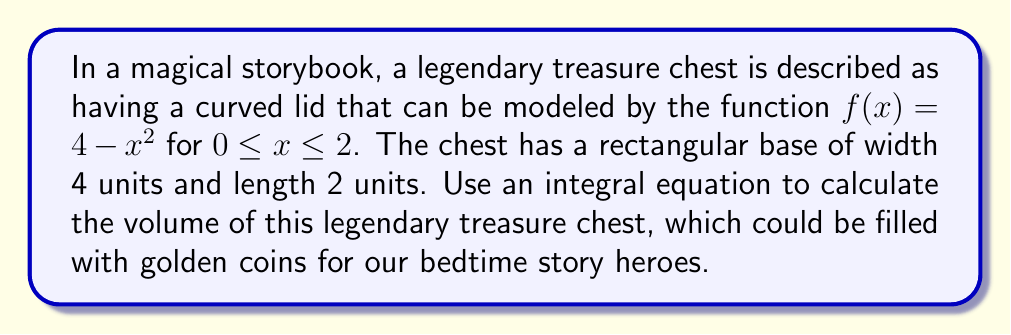Could you help me with this problem? Let's approach this problem step-by-step:

1) The volume of the chest can be calculated using the method of slicing. We'll consider vertical slices perpendicular to the x-axis.

2) Each slice is approximately a rectangle with:
   - Height: $f(x) = 4 - x^2$
   - Width: $dx$ (infinitesimally small)
   - Length: 4 units (the width of the chest's base)

3) The volume of each slice is approximately:
   $dV = 4(4 - x^2)dx$

4) To get the total volume, we need to integrate this over the length of the chest (from 0 to 2):

   $$V = \int_0^2 4(4 - x^2)dx$$

5) Let's solve this integral:
   $$V = 4\int_0^2 (4 - x^2)dx$$
   $$V = 4[4x - \frac{1}{3}x^3]_0^2$$

6) Evaluating the integral:
   $$V = 4[(8 - \frac{8}{3}) - (0 - 0)]$$
   $$V = 4(8 - \frac{8}{3})$$
   $$V = 4(\frac{24}{3} - \frac{8}{3})$$
   $$V = 4(\frac{16}{3})$$
   $$V = \frac{64}{3}$$

Therefore, the volume of the legendary treasure chest is $\frac{64}{3}$ cubic units.
Answer: $\frac{64}{3}$ cubic units 